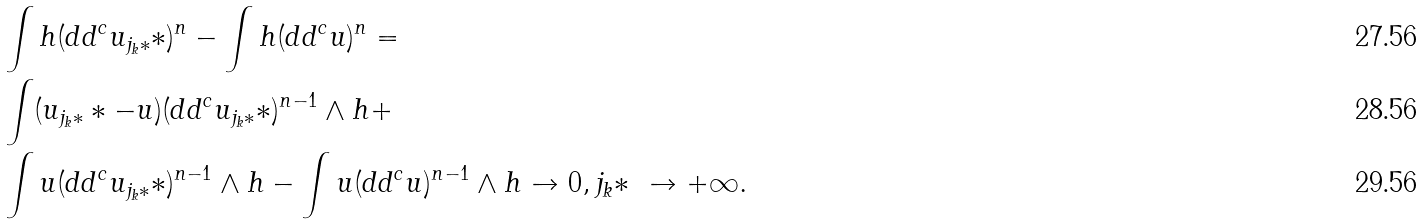Convert formula to latex. <formula><loc_0><loc_0><loc_500><loc_500>& \int h ( d d ^ { c } u _ { j _ { k } * } * ) ^ { n } - \int h ( d d ^ { c } u ) ^ { n } = \\ & \int ( u _ { j _ { k } * } * - u ) ( d d ^ { c } u _ { j _ { k } * } * ) ^ { n - 1 } \land h + \\ & \int u ( d d ^ { c } u _ { j _ { k } * } * ) ^ { n - 1 } \land h - \int u ( d d ^ { c } u ) ^ { n - 1 } \land h \to 0 , j _ { k } * \ \to + \infty .</formula> 